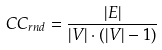Convert formula to latex. <formula><loc_0><loc_0><loc_500><loc_500>C C _ { r n d } = \frac { | E | } { | V | \cdot ( | V | - 1 ) }</formula> 